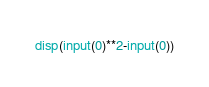Convert code to text. <code><loc_0><loc_0><loc_500><loc_500><_Octave_>disp(input(0)**2-input(0))</code> 